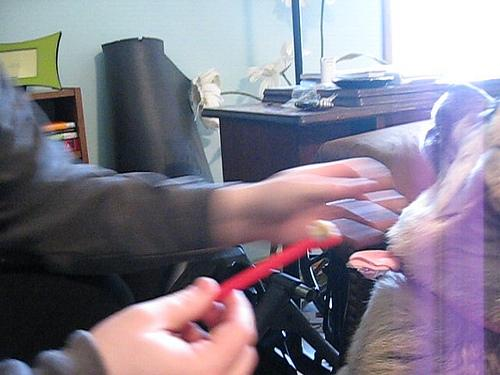What is the person trying to do to the dog?

Choices:
A) brush teeth
B) clean eyes
C) tighten color
D) cut nails brush teeth 